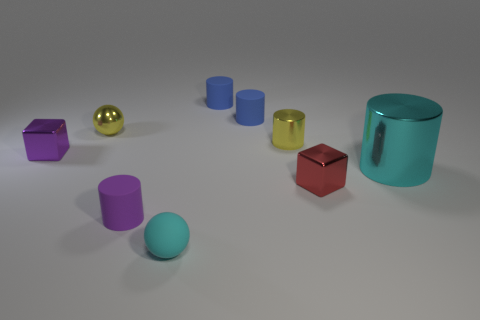Can you tell me the colors of the cylindrical objects? Certainly, there are three cylindrical objects and their colors are blue, yellow, and teal. 